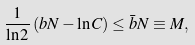Convert formula to latex. <formula><loc_0><loc_0><loc_500><loc_500>\frac { 1 } { \ln 2 } \left ( b N - \ln C \right ) \leq \bar { b } N \equiv M ,</formula> 